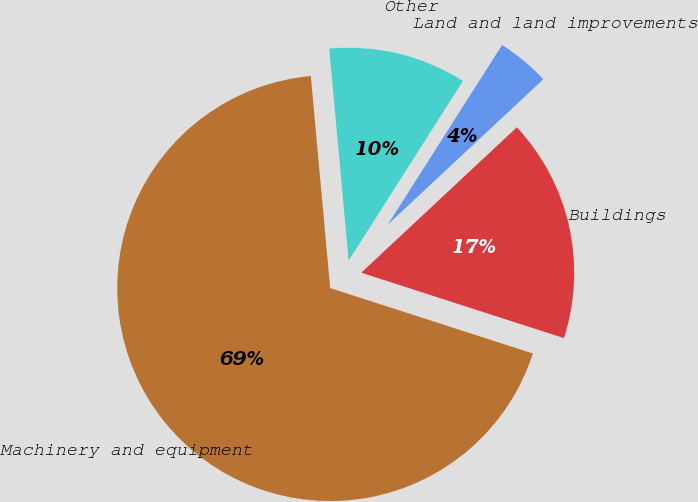Convert chart. <chart><loc_0><loc_0><loc_500><loc_500><pie_chart><fcel>Land and land improvements<fcel>Buildings<fcel>Machinery and equipment<fcel>Other<nl><fcel>4.02%<fcel>16.93%<fcel>68.58%<fcel>10.47%<nl></chart> 